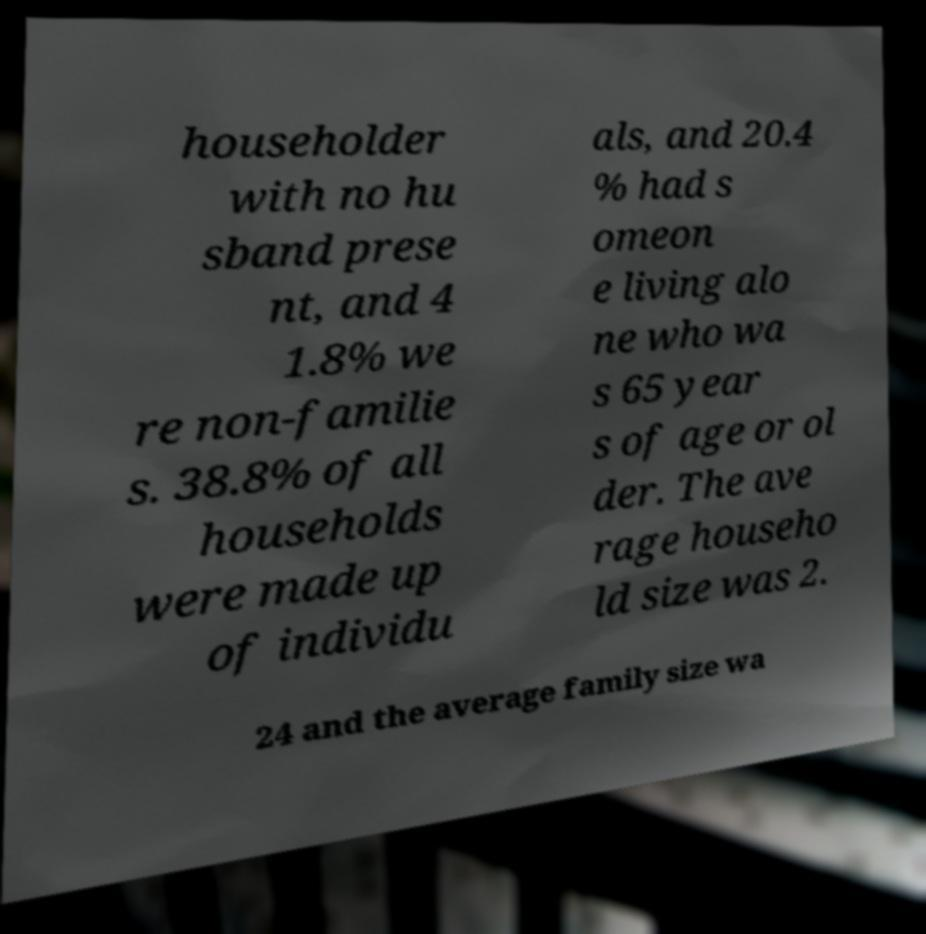Please read and relay the text visible in this image. What does it say? householder with no hu sband prese nt, and 4 1.8% we re non-familie s. 38.8% of all households were made up of individu als, and 20.4 % had s omeon e living alo ne who wa s 65 year s of age or ol der. The ave rage househo ld size was 2. 24 and the average family size wa 